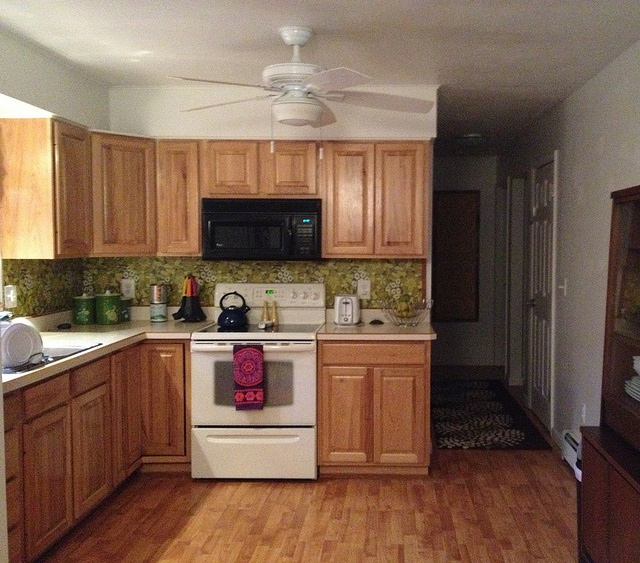Describe the objects in this image and their specific colors. I can see oven in lightgray, tan, and gray tones, microwave in lightgray, black, gray, and maroon tones, bowl in lightgray, olive, gray, and maroon tones, toaster in lightgray, darkgray, and gray tones, and sink in lightgray, darkgray, gray, and black tones in this image. 